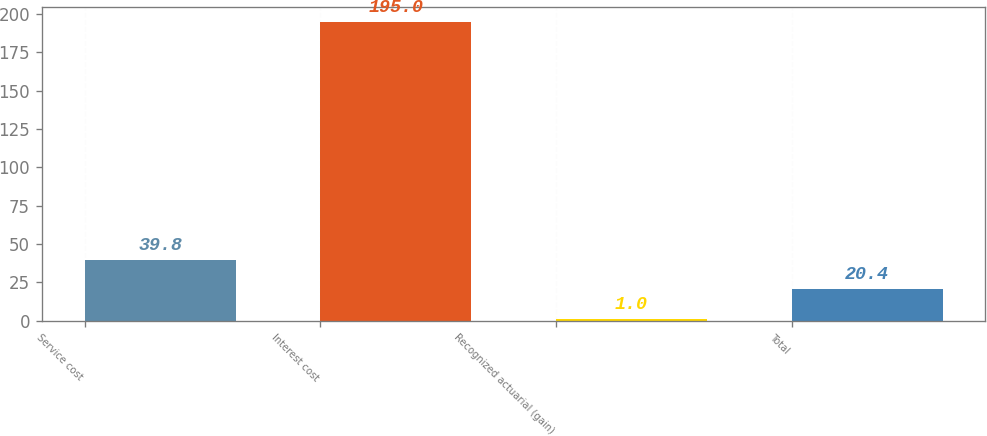<chart> <loc_0><loc_0><loc_500><loc_500><bar_chart><fcel>Service cost<fcel>Interest cost<fcel>Recognized actuarial (gain)<fcel>Total<nl><fcel>39.8<fcel>195<fcel>1<fcel>20.4<nl></chart> 